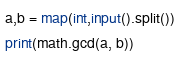Convert code to text. <code><loc_0><loc_0><loc_500><loc_500><_Python_>a,b = map(int,input().split())
print(math.gcd(a, b))</code> 